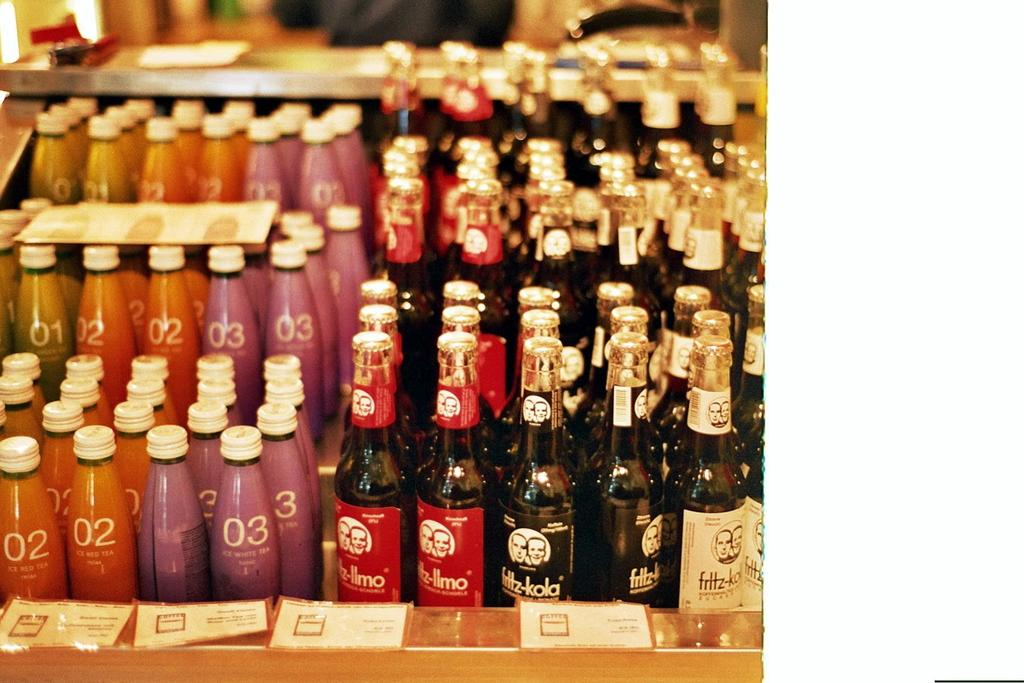<image>
Present a compact description of the photo's key features. Bottles of Fritz-Kola and Bottles of Ice White Tea. 